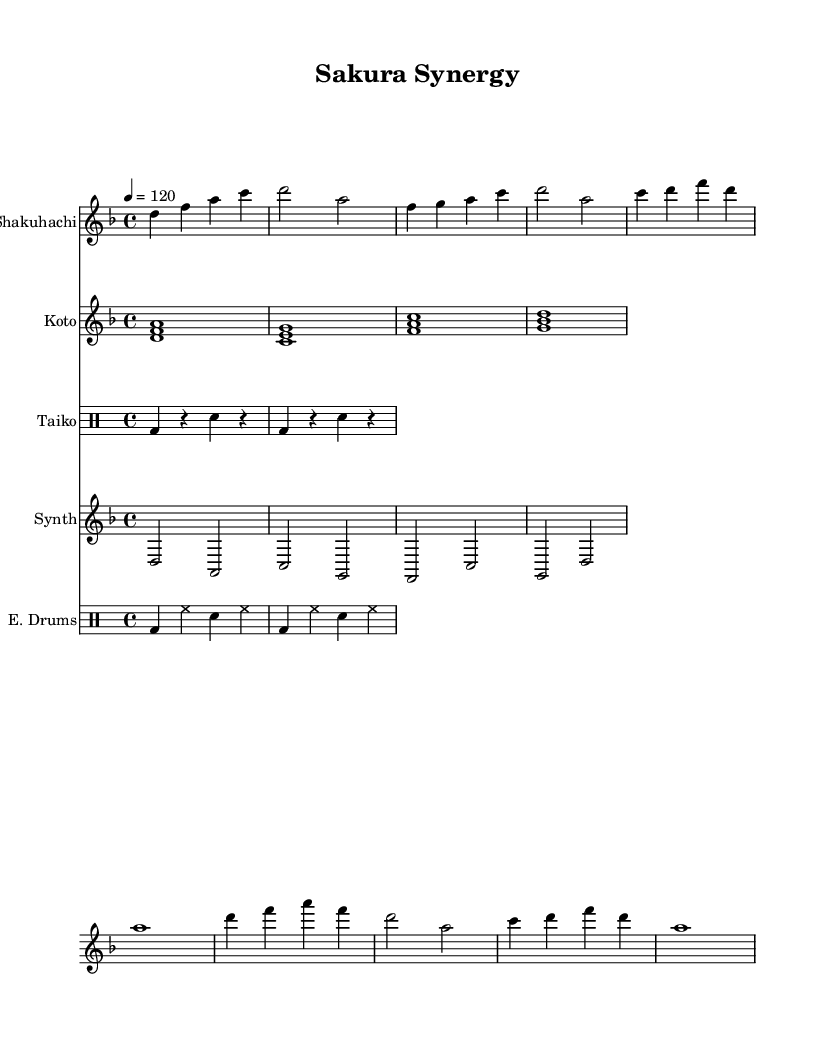What is the key signature of this music? The key signature of the music is indicated at the beginning, showing two flat symbols which signifies B flat and E flat. This means the key signature is D minor.
Answer: D minor What is the time signature of this music? The time signature is shown after the key signature, represented by the figures 4 and 4, which indicates that there are four beats per measure and a quarter note gets one beat.
Answer: 4/4 What is the tempo marking of this piece? The tempo marking is provided as "4 = 120," which instructs the performer to play at a tempo of 120 beats per minute, with each "4" representing a quarter note.
Answer: 120 How many different instrumental parts are present in this sheet music? By looking at the score, there are five distinct parts: Shakuhachi, Koto, Taiko, Synth, and E. Drums, indicating a blend of traditional and contemporary sounds.
Answer: Five What is the rhythmic pattern used in the Taiko part? The Taiko part uses a simple rhythmic pattern alternating between bass drum (bd) and snare (sn), specifically featuring two measures of bass drum followed by snare in each. This simple pattern aligns with traditional Taiko drumming styles, providing a steady beat.
Answer: Bass drum and snare Which traditional Japanese instrument is featured first in the score? The first instrument part in the score is for the Shakuhachi, which is a traditional Japanese bamboo flute known for its breathy and meditative sound, as it is written before the Koto and any percussion instruments.
Answer: Shakuhachi What is the duration of the longest note in the Shakuhachi part? In the Shakuhachi part, the longest note is a whole note (a note with the duration of four beats), specifically the note "a" towards the end of the score, indicating it is sustained for an entire measure.
Answer: Whole note 